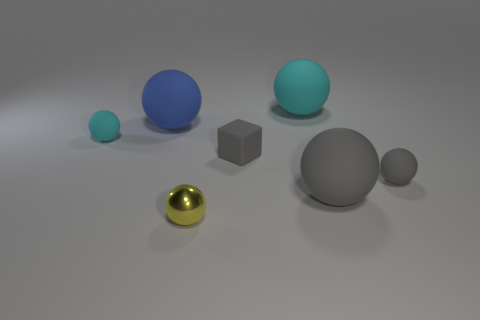Subtract all small yellow metal spheres. How many spheres are left? 5 Subtract all yellow spheres. How many spheres are left? 5 Subtract all cubes. How many objects are left? 6 Add 2 blue matte objects. How many objects exist? 9 Add 7 large things. How many large things are left? 10 Add 4 yellow metal cubes. How many yellow metal cubes exist? 4 Subtract 0 purple balls. How many objects are left? 7 Subtract 4 spheres. How many spheres are left? 2 Subtract all green spheres. Subtract all gray blocks. How many spheres are left? 6 Subtract all brown cubes. How many green balls are left? 0 